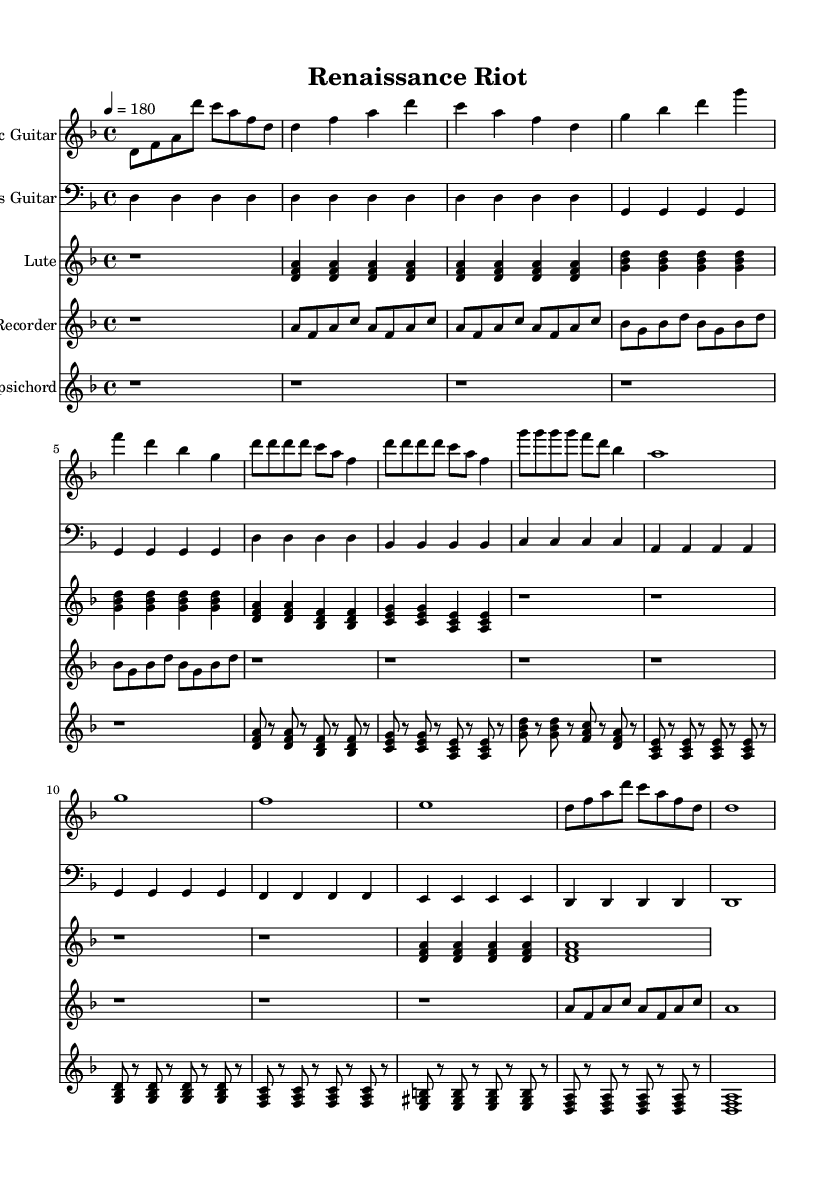what is the key signature of this music? The key signature is D minor, which features one flat (B♭) in its scale. This can be identified at the beginning of the sheet music where the key signature is stated.
Answer: D minor what is the time signature of this music? The time signature is 4/4, which is indicated at the beginning of the score. This means there are four beats per measure and the quarter note gets one beat.
Answer: 4/4 what is the tempo marking of this music? The tempo marking is quarter note equals 180 which indicates a fast pace for the piece. It can be found in the tempo directive line right after the time signature.
Answer: 180 how many measures does the electric guitar part have? The electric guitar part consists of 11 measures, which can be counted by locating the vertical barlines that separate each measure throughout the staff.
Answer: 11 which instrument plays the opening chord of the composition? The lute plays the opening chord which is indicated by the chord symbols at the start of its staff. This can be seen in the sheet music where the lute's part is displayed.
Answer: Lute how many times does the bass guitar play before the harpsichord enters? The bass guitar plays 11 times before the harpsichord enters, counting all the measures it plays in its part leading up to the entrance of the harpsichord, which starts later in the score.
Answer: 11 which instruments are featured in this composition? The instruments featured are Electric Guitar, Bass Guitar, Lute, Recorder, and Harpsichord, as each instrument has its distinct staff labeled at the beginning of the score.
Answer: Electric Guitar, Bass Guitar, Lute, Recorder, Harpsichord 